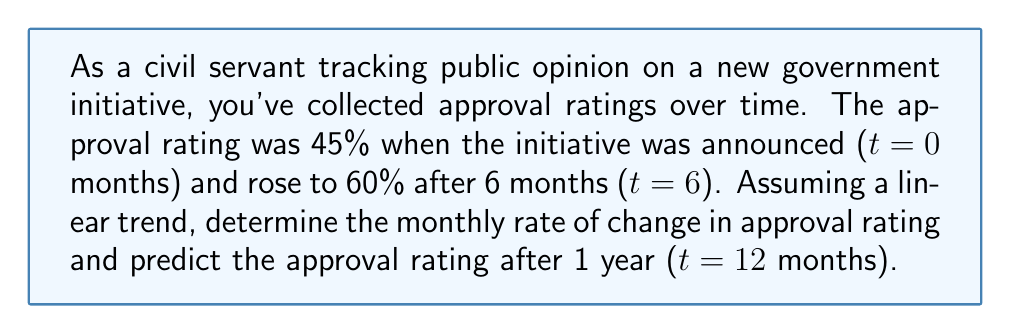Can you solve this math problem? Let's approach this step-by-step:

1) We can use the slope formula to calculate the rate of change:

   $$ m = \frac{y_2 - y_1}{x_2 - x_1} $$

   Where $(x_1, y_1)$ is the initial point and $(x_2, y_2)$ is the final point.

2) Plugging in our values:
   $(x_1, y_1) = (0, 45)$ and $(x_2, y_2) = (6, 60)$

   $$ m = \frac{60 - 45}{6 - 0} = \frac{15}{6} = 2.5 $$

3) This means the approval rating is increasing by 2.5 percentage points per month.

4) Now, to predict the approval rating after 1 year, we can use the point-slope form of a line:

   $$ y - y_1 = m(x - x_1) $$

5) Using the initial point $(0, 45)$ and our calculated slope:

   $$ y - 45 = 2.5(x - 0) $$

6) Simplify:

   $$ y = 2.5x + 45 $$

7) To find the approval rating at 12 months, substitute $x = 12$:

   $$ y = 2.5(12) + 45 = 30 + 45 = 75 $$

Therefore, the predicted approval rating after 1 year is 75%.
Answer: 2.5 percentage points per month; 75% 